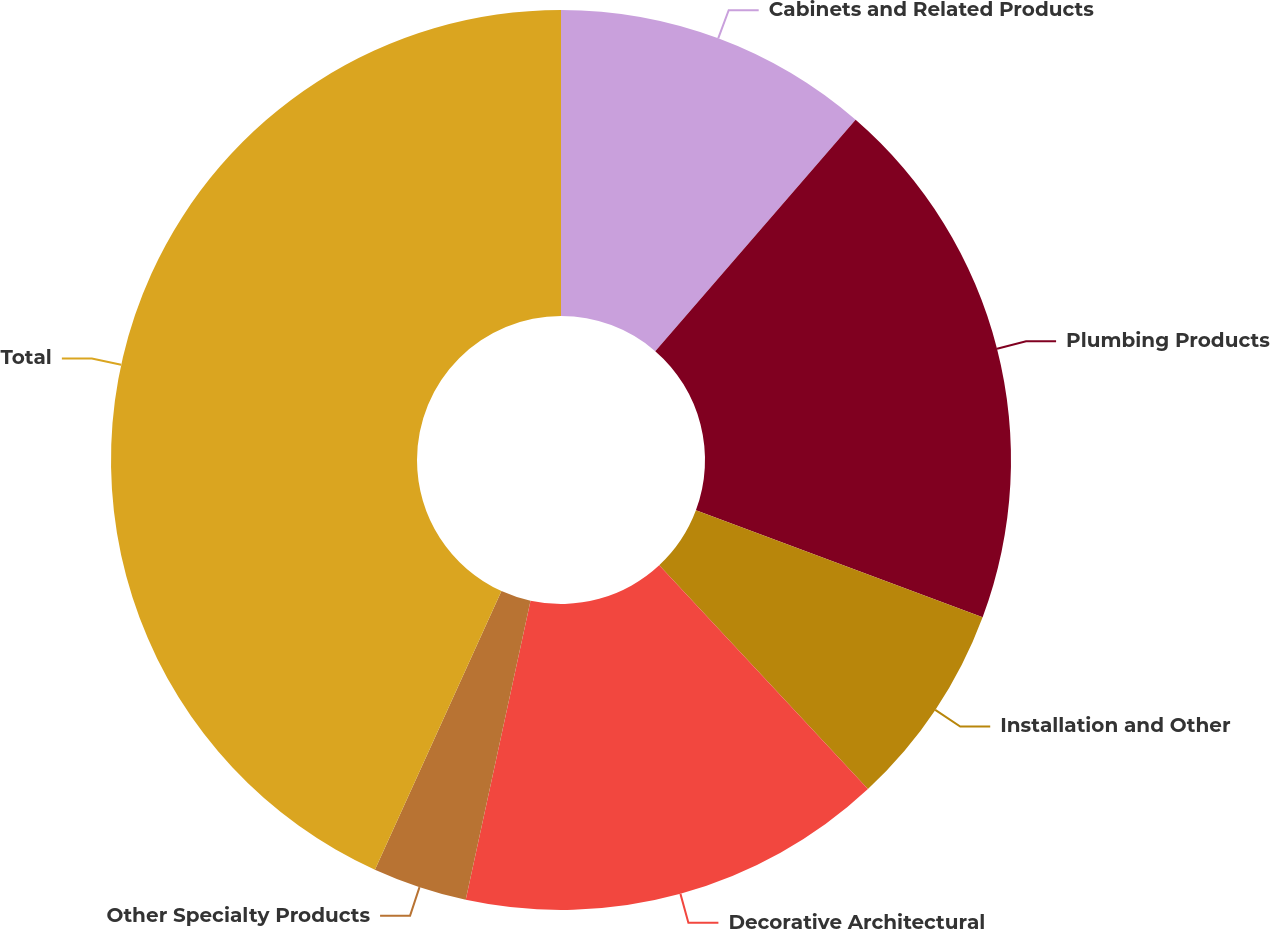Convert chart. <chart><loc_0><loc_0><loc_500><loc_500><pie_chart><fcel>Cabinets and Related Products<fcel>Plumbing Products<fcel>Installation and Other<fcel>Decorative Architectural<fcel>Other Specialty Products<fcel>Total<nl><fcel>11.36%<fcel>19.32%<fcel>7.37%<fcel>15.34%<fcel>3.39%<fcel>43.21%<nl></chart> 